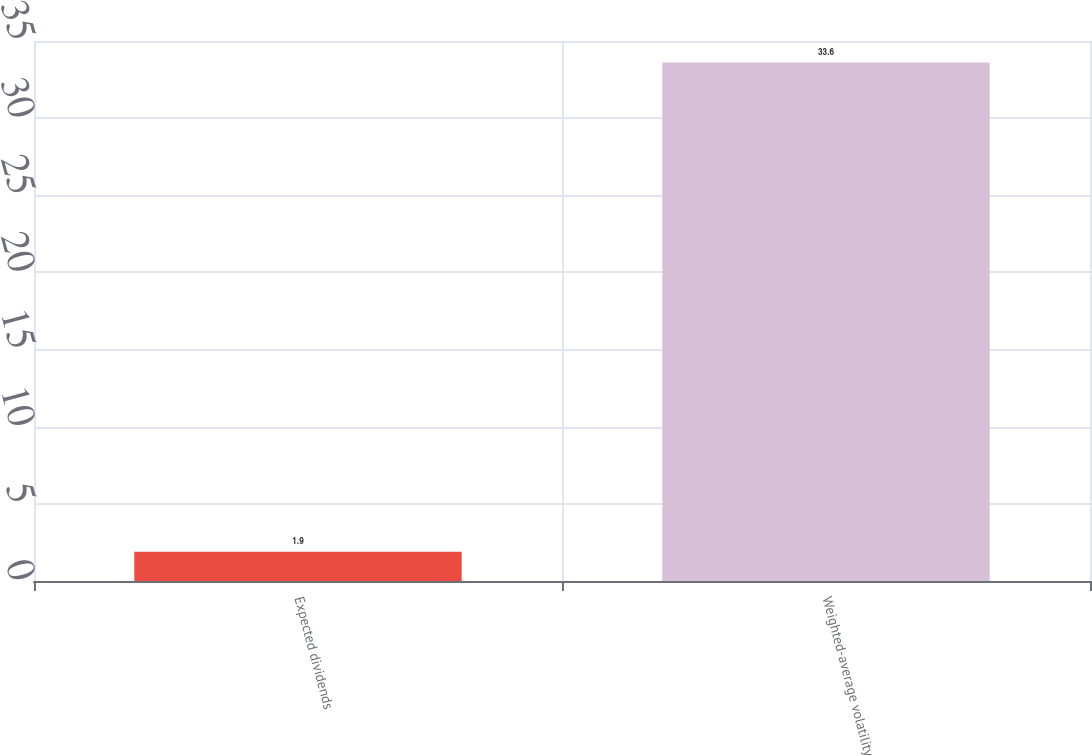Convert chart to OTSL. <chart><loc_0><loc_0><loc_500><loc_500><bar_chart><fcel>Expected dividends<fcel>Weighted-average volatility<nl><fcel>1.9<fcel>33.6<nl></chart> 